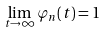Convert formula to latex. <formula><loc_0><loc_0><loc_500><loc_500>\lim _ { t \to \infty } \varphi _ { n } ( t ) = 1</formula> 